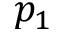Convert formula to latex. <formula><loc_0><loc_0><loc_500><loc_500>p _ { 1 }</formula> 